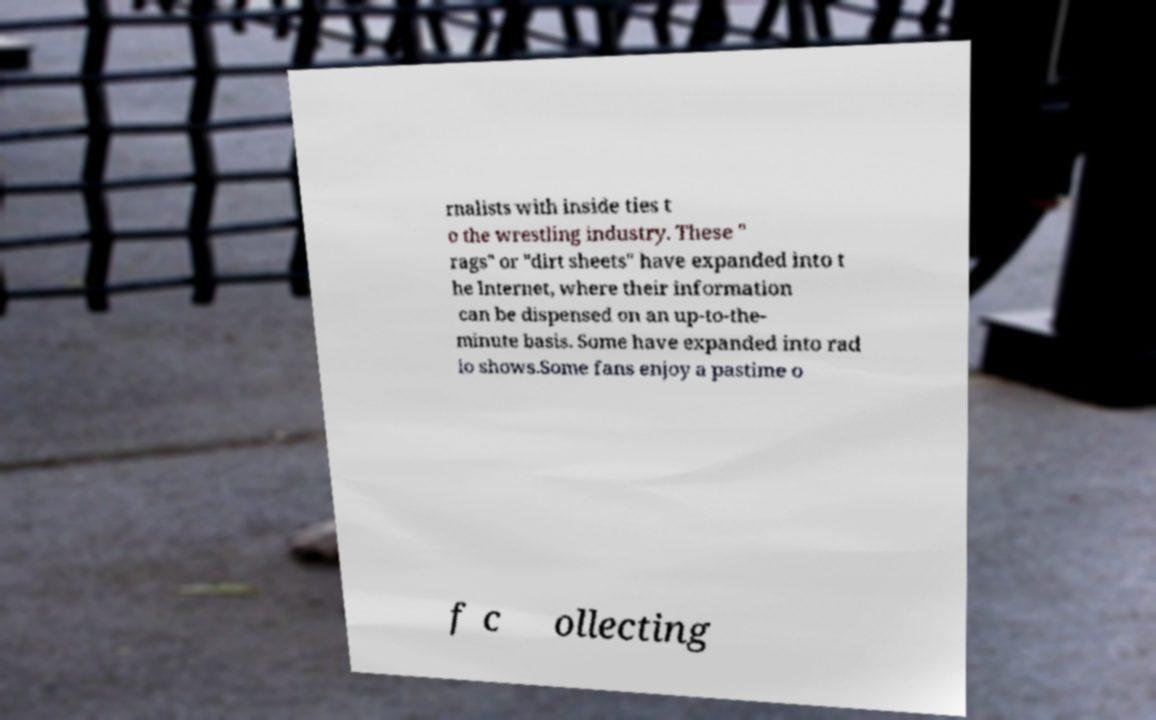I need the written content from this picture converted into text. Can you do that? rnalists with inside ties t o the wrestling industry. These " rags" or "dirt sheets" have expanded into t he Internet, where their information can be dispensed on an up-to-the- minute basis. Some have expanded into rad io shows.Some fans enjoy a pastime o f c ollecting 